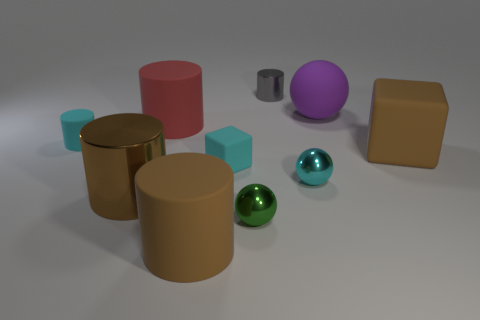Subtract all gray cylinders. How many cylinders are left? 4 Subtract all red cylinders. How many cylinders are left? 4 Subtract all green cylinders. Subtract all red balls. How many cylinders are left? 5 Subtract all balls. How many objects are left? 7 Subtract all rubber cylinders. Subtract all large brown rubber cylinders. How many objects are left? 6 Add 8 gray things. How many gray things are left? 9 Add 10 large metallic balls. How many large metallic balls exist? 10 Subtract 0 red spheres. How many objects are left? 10 